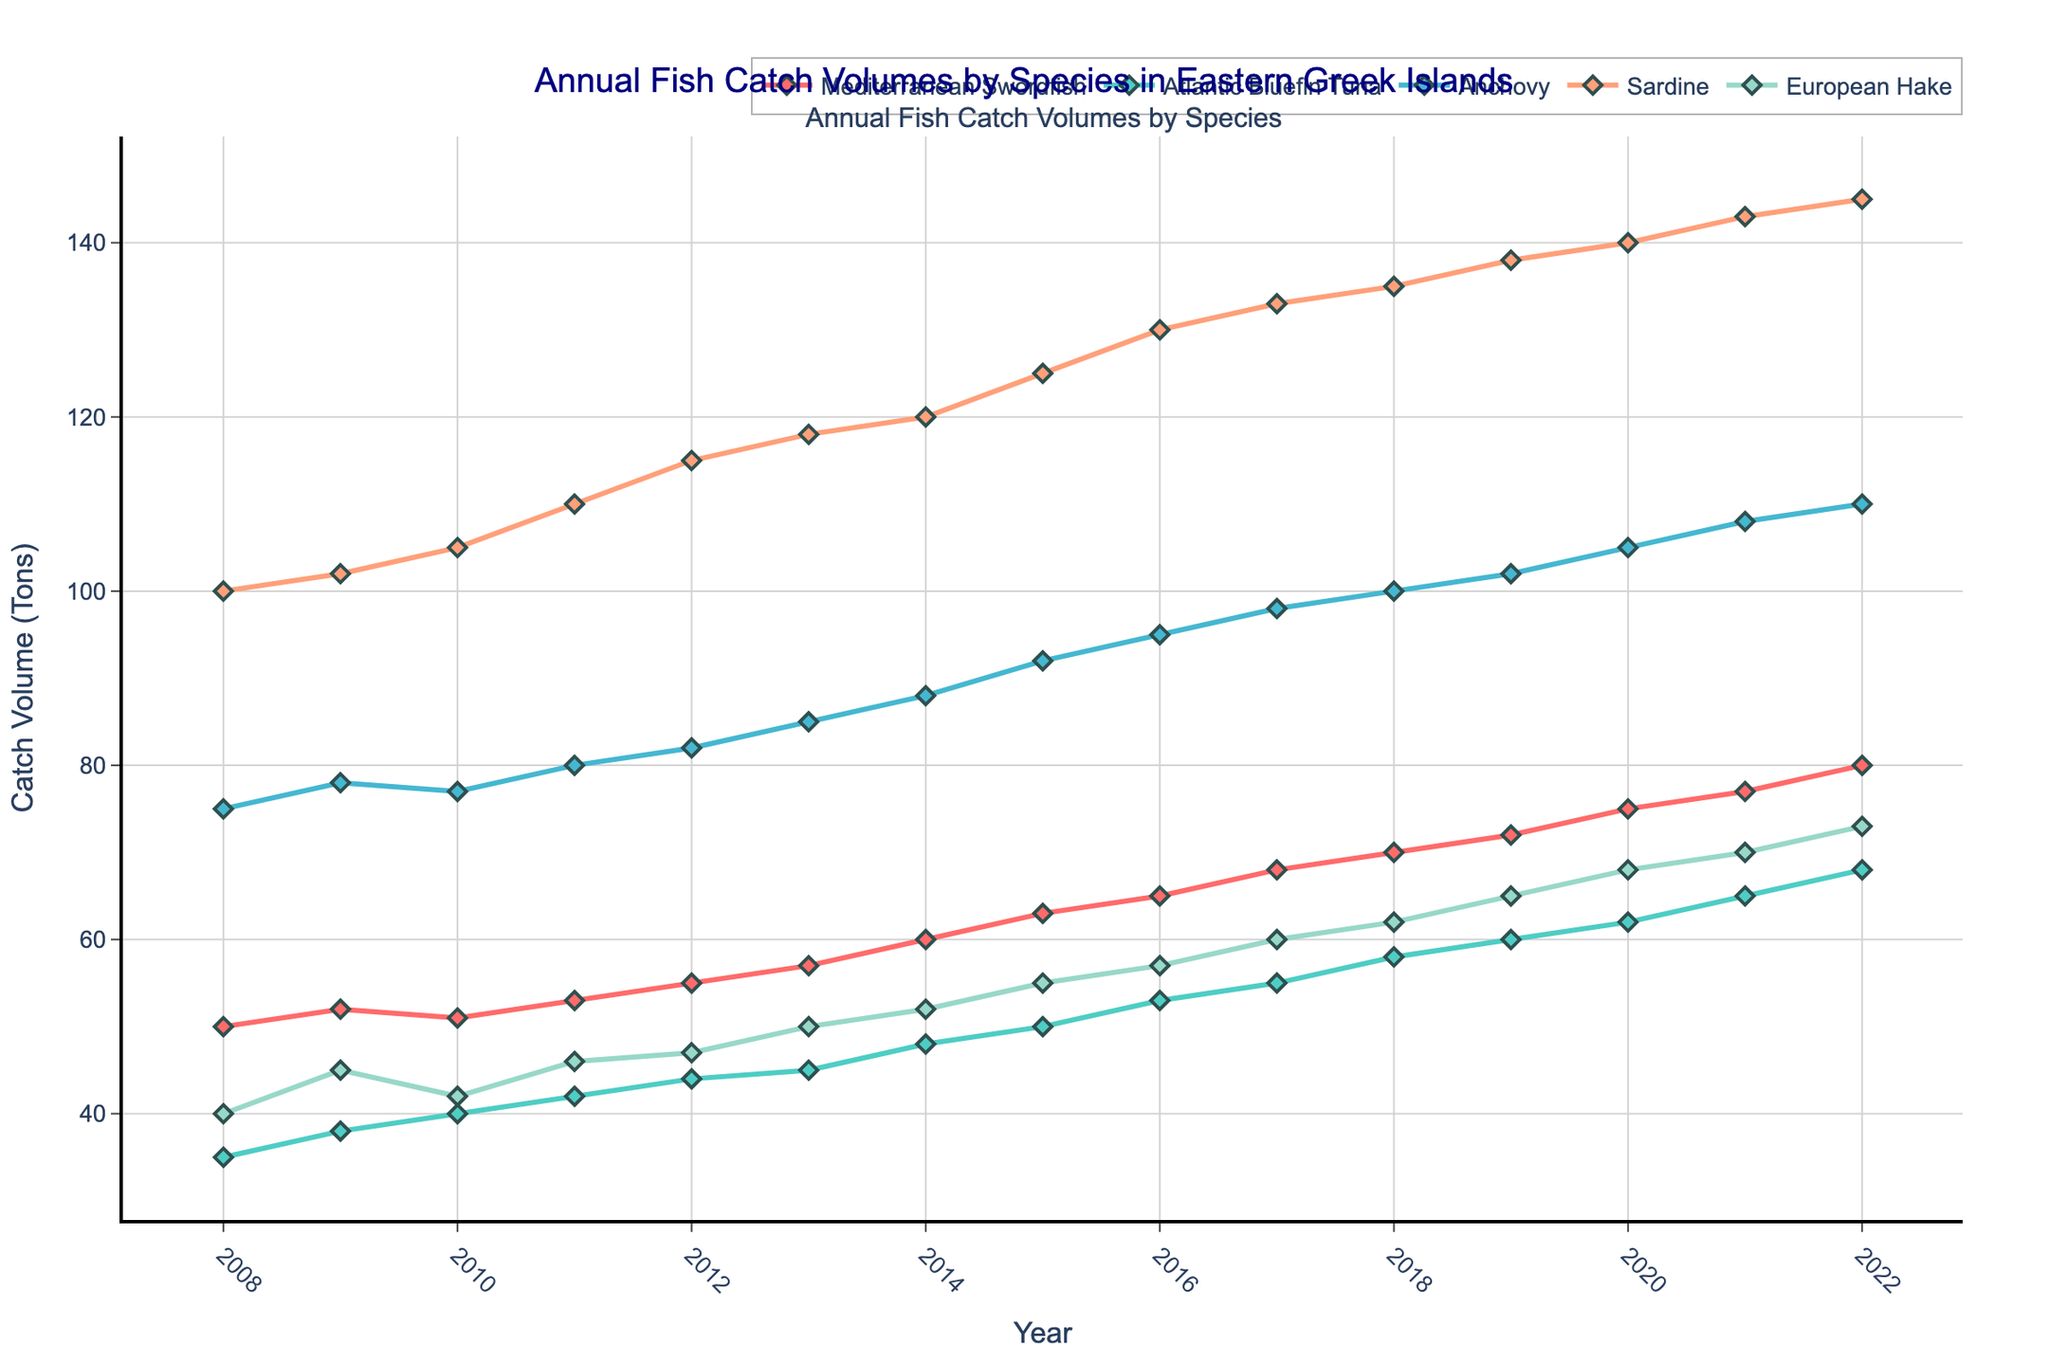What is the title of the figure? The title of the figure is clearly mentioned at the top of the plot in a larger font size, typically to provide an overview of the data being presented.
Answer: Annual Fish Catch Volumes by Species in Eastern Greek Islands How many fish species are tracked in this figure? Each unique colored line in the plot represents a different fish species. By counting these lines, we can determine the number of species tracked.
Answer: 5 What trend does the catch volume of Mediterranean Swordfish show over the years? By examining the line for Mediterranean Swordfish from the start to the end year, we observe the direction and slope to determine if it is increasing, decreasing, or stable.
Answer: Increasing Which year shows the highest catch volume for Sardine? Find the peak point in the graph for the Sardine's specific line. The x-axis corresponding to this peak indicates the year.
Answer: 2022 Which fish species shows the smallest volume increase over the 15 years? Calculate the change in catch volume from the first year to the last year for each species by subtracting the initial value from the final value. The species with the smallest positive difference shows the least increase.
Answer: Mediterranean Swordfish How does the catch volume of European Hake change between 2008 and 2012? Look at the start and end points of the European Hake line over the indicated period and note the change in volume.
Answer: Increases from 40 tons to 47 tons What is the combined catch volume of Anchovy and Atlantic Bluefin Tuna in 2010? Find the volumes of Anchovy and Atlantic Bluefin Tuna for the year 2010, then sum these two values together.
Answer: 77 + 40 = 117 tons Is there any year where all species show an increasing trend compared to the previous year? Check if each species line shows an upward movement from one specific year to the next for any year in the range.
Answer: 2014 Which species had a higher catch volume in 2020: Anchovy or Atlantic Bluefin Tuna? Compare the data points for Anchovy and Atlantic Bluefin Tuna for the year 2020 to determine which one is higher.
Answer: Anchovy By how many tons did the Sardine catch volume increase from 2008 to 2022? Subtract the Sardine catch volume in 2008 from the volume in 2022 to find the increase.
Answer: 145 - 100 = 45 tons 